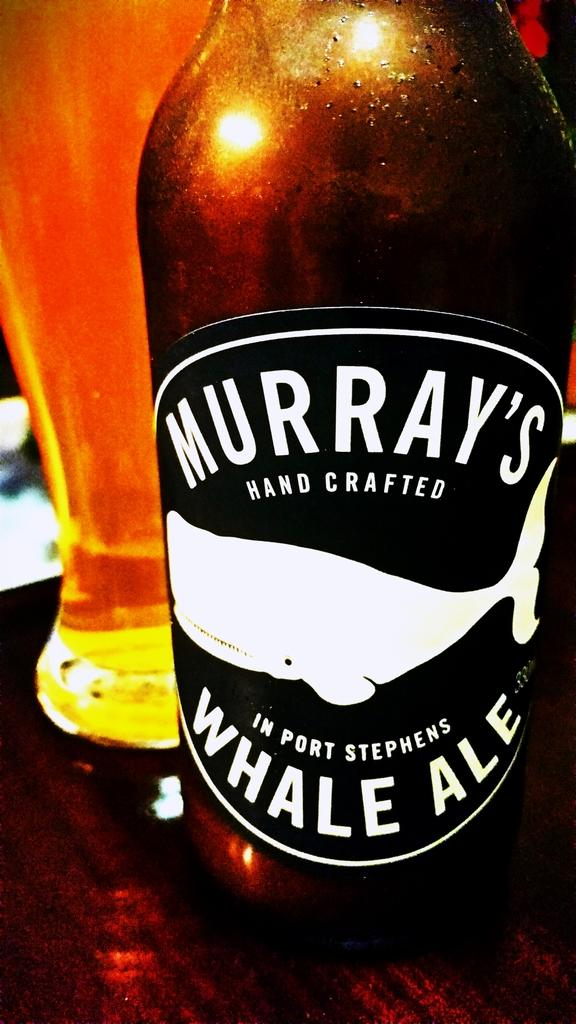<image>
Provide a brief description of the given image. a bottle of murray's hand crafted in port stephens whale ale 